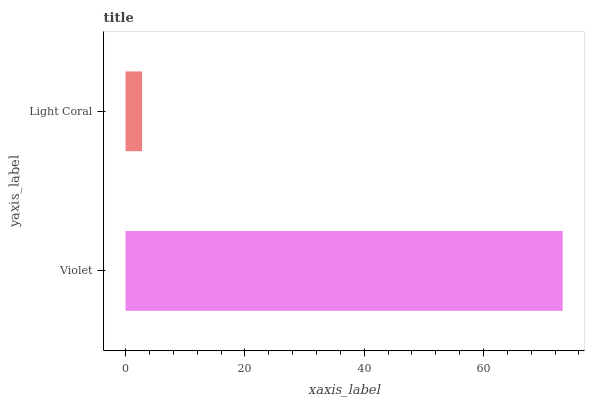Is Light Coral the minimum?
Answer yes or no. Yes. Is Violet the maximum?
Answer yes or no. Yes. Is Light Coral the maximum?
Answer yes or no. No. Is Violet greater than Light Coral?
Answer yes or no. Yes. Is Light Coral less than Violet?
Answer yes or no. Yes. Is Light Coral greater than Violet?
Answer yes or no. No. Is Violet less than Light Coral?
Answer yes or no. No. Is Violet the high median?
Answer yes or no. Yes. Is Light Coral the low median?
Answer yes or no. Yes. Is Light Coral the high median?
Answer yes or no. No. Is Violet the low median?
Answer yes or no. No. 